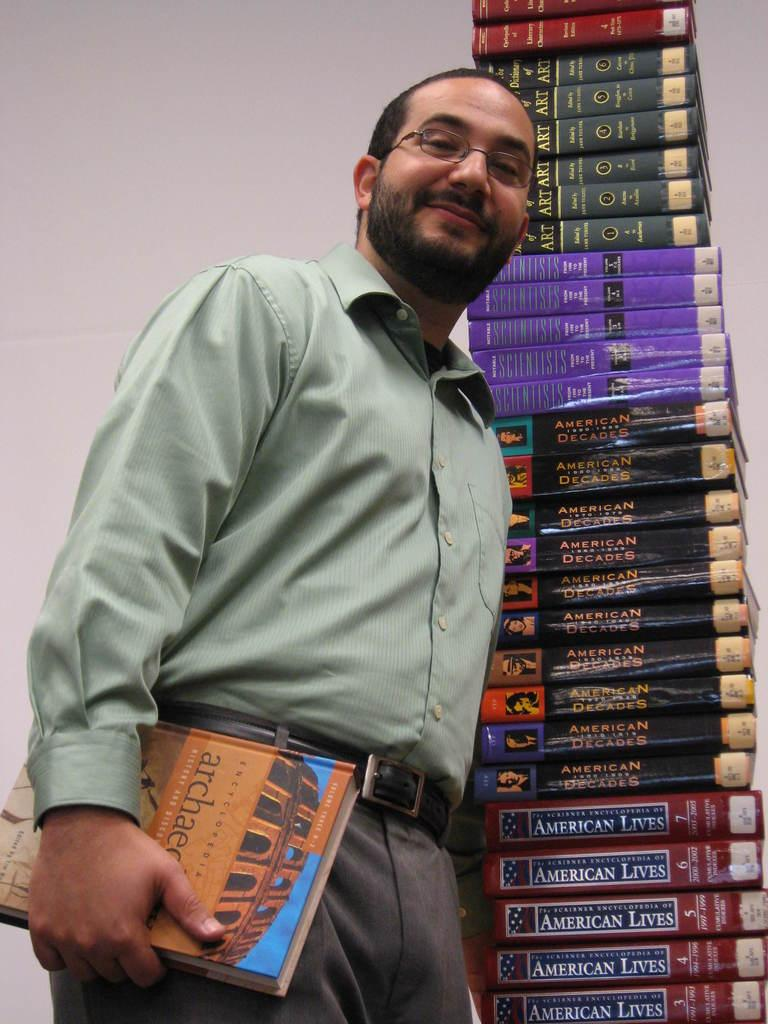<image>
Write a terse but informative summary of the picture. A person standing in front of books with American Lives on them 